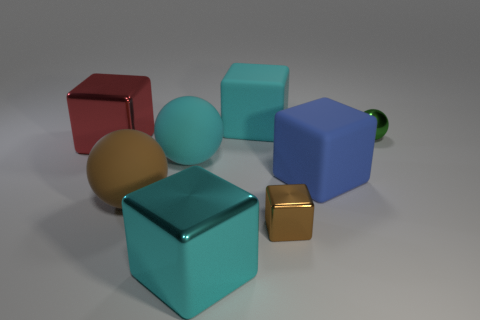Subtract all small shiny blocks. How many blocks are left? 4 Subtract all red blocks. How many blocks are left? 4 Subtract all purple cubes. Subtract all green balls. How many cubes are left? 5 Add 1 large cyan rubber cubes. How many objects exist? 9 Subtract all cubes. How many objects are left? 3 Subtract 0 green cylinders. How many objects are left? 8 Subtract all big red cubes. Subtract all green metal spheres. How many objects are left? 6 Add 8 green shiny objects. How many green shiny objects are left? 9 Add 6 brown metal things. How many brown metal things exist? 7 